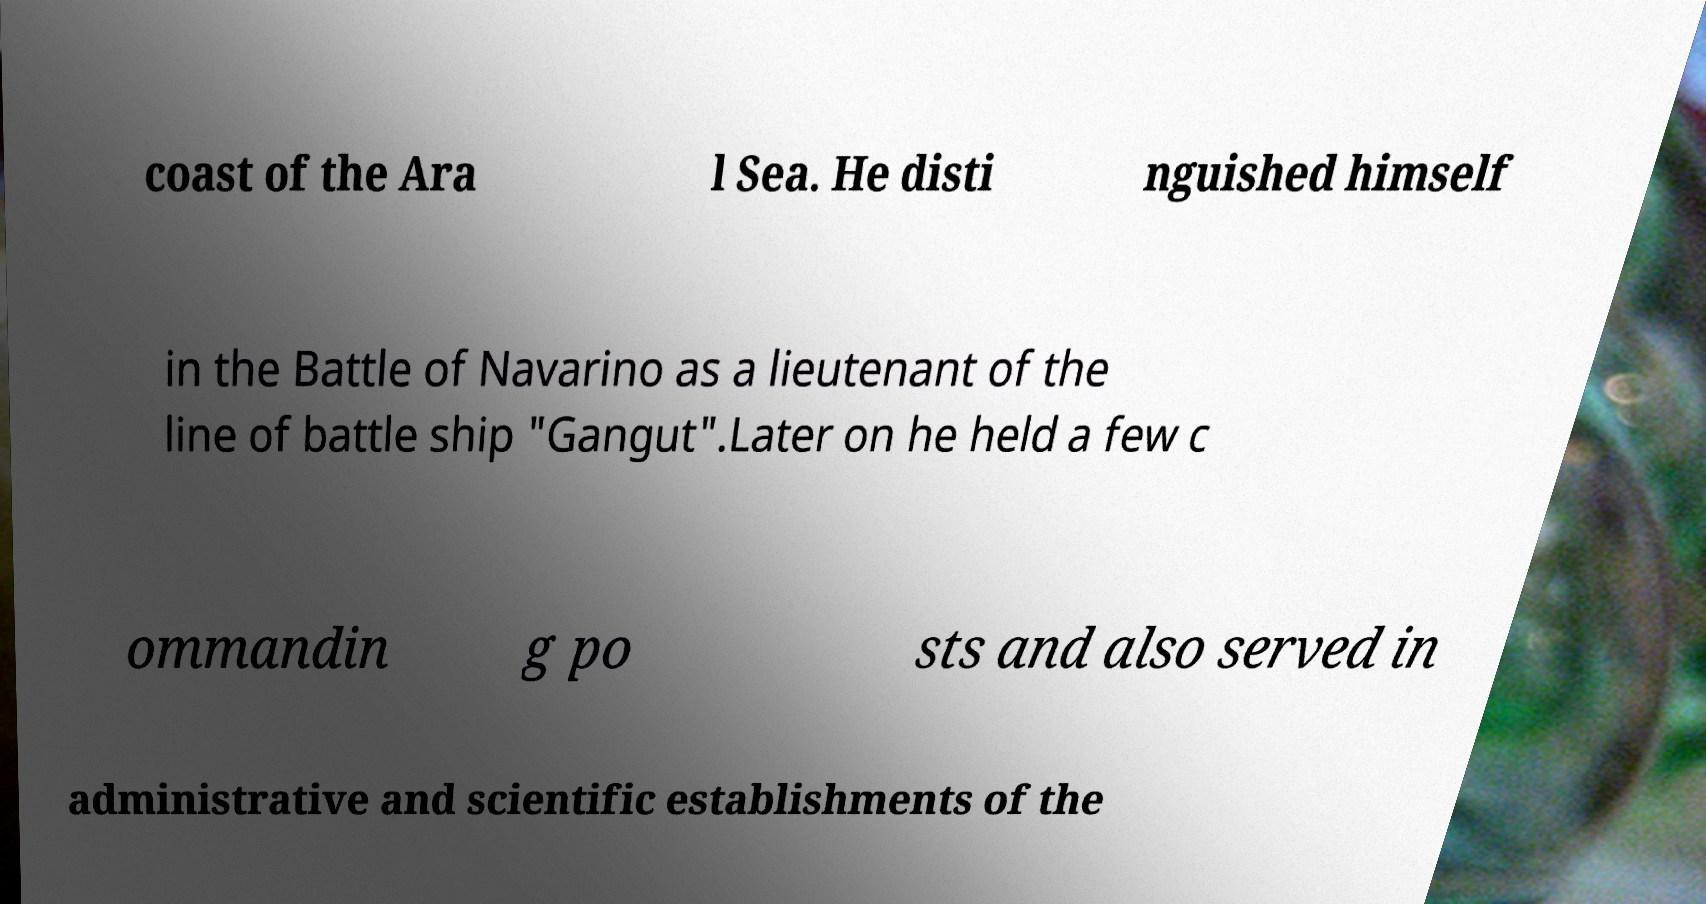Can you accurately transcribe the text from the provided image for me? coast of the Ara l Sea. He disti nguished himself in the Battle of Navarino as a lieutenant of the line of battle ship "Gangut".Later on he held a few c ommandin g po sts and also served in administrative and scientific establishments of the 